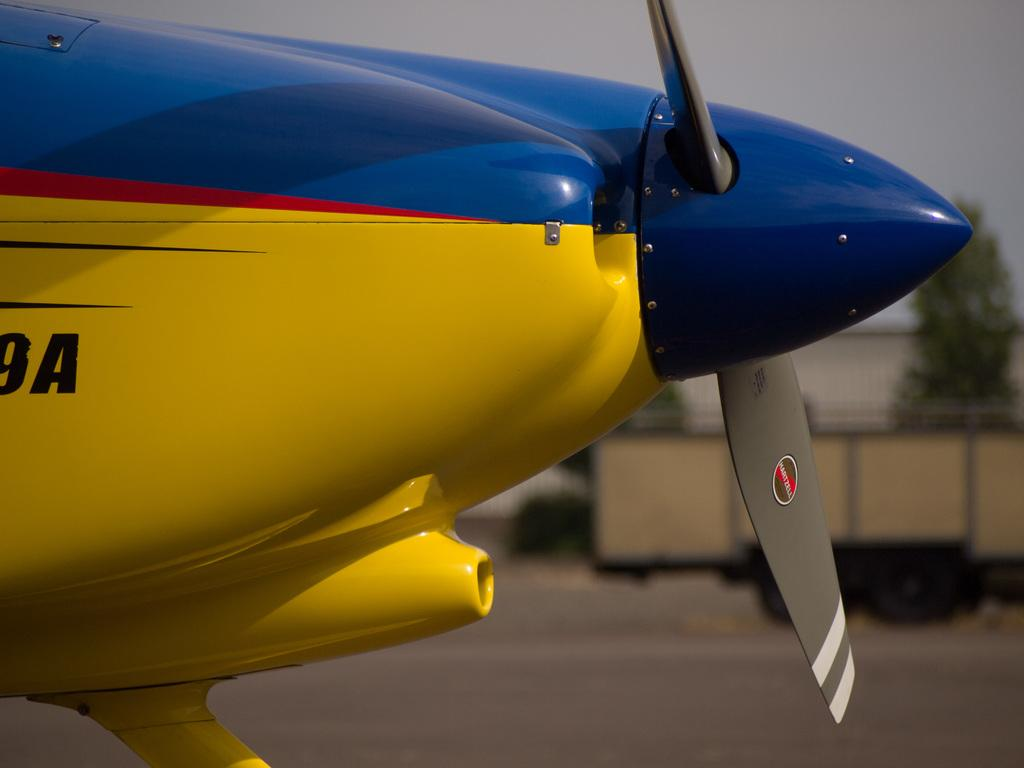What is the main subject of the picture? The main subject of the picture is an airplane. What colors are used for the airplane? The airplane is in blue and yellow color. Where is the airplane located in the picture? The airplane is in the middle of the picture. What else can be seen on the right side of the picture? There is a spinner on the right side of the picture. How would you describe the background of the image? The background of the image is blurred. What type of suit is visible on the bed in the image? There is no suit or bed present in the image; it features an airplane in the middle with a blurred background. 